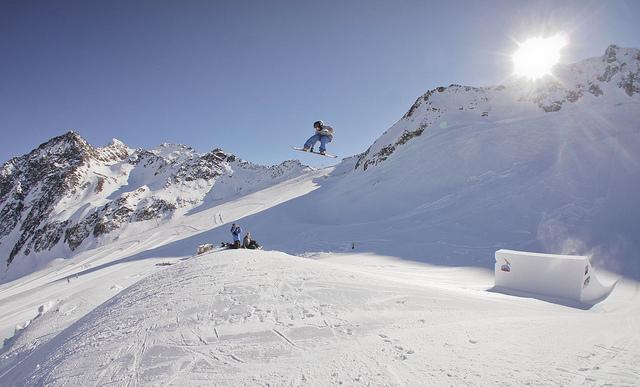How many trains are in front of the building?
Give a very brief answer. 0. 